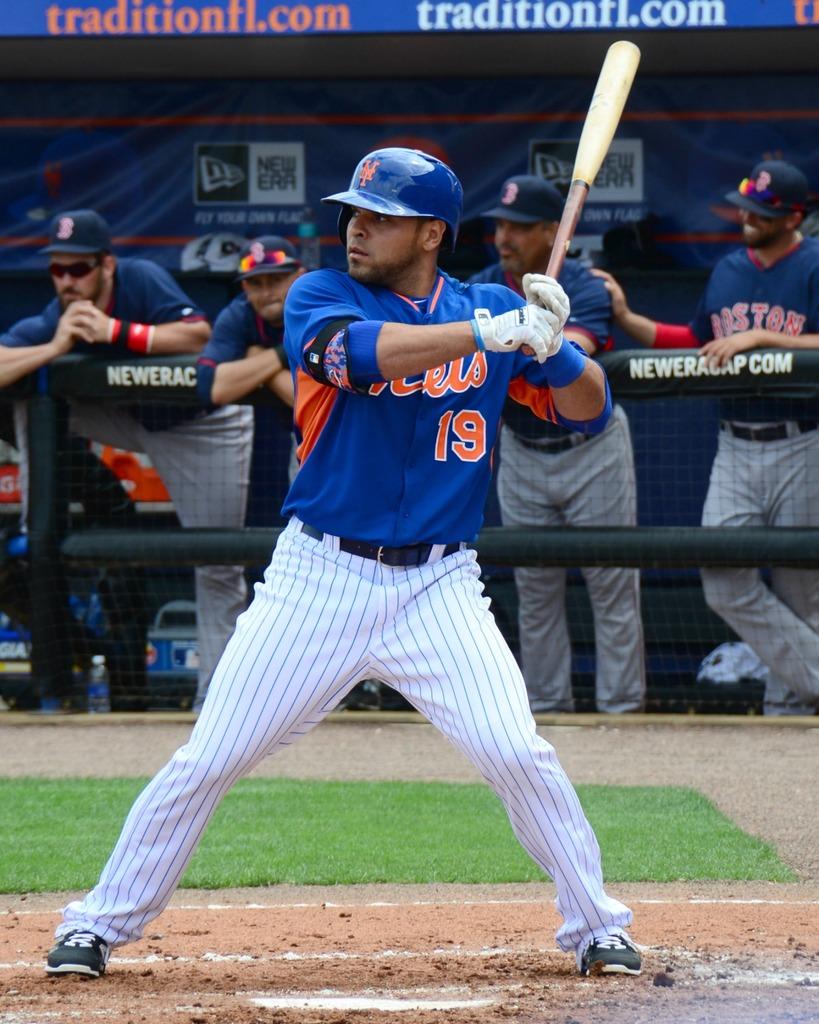What is the player's numner?
Your answer should be very brief. 19. 